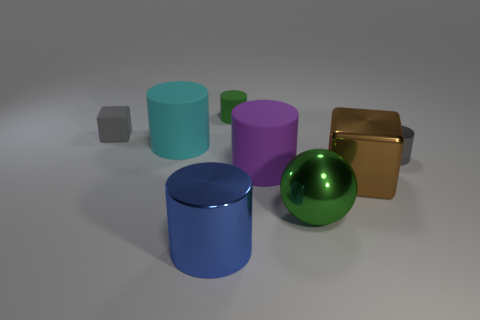Is there anything else that has the same color as the large metal cube?
Your answer should be very brief. No. There is a gray thing that is to the left of the green thing behind the big green metal object; what shape is it?
Make the answer very short. Cube. Is the number of large metallic blocks greater than the number of big cyan metal things?
Keep it short and to the point. Yes. What number of large metal things are both in front of the large green thing and right of the large metallic cylinder?
Your answer should be very brief. 0. There is a green object on the right side of the purple cylinder; what number of gray cylinders are behind it?
Give a very brief answer. 1. How many objects are either small gray objects to the right of the green shiny ball or big shiny blocks left of the small metal thing?
Your answer should be compact. 2. There is a gray thing that is the same shape as the small green thing; what material is it?
Give a very brief answer. Metal. What number of things are either cylinders that are in front of the big green metallic object or blue objects?
Offer a terse response. 1. There is a large green object that is made of the same material as the gray cylinder; what is its shape?
Provide a short and direct response. Sphere. How many gray metallic objects have the same shape as the brown thing?
Your answer should be compact. 0. 